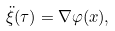Convert formula to latex. <formula><loc_0><loc_0><loc_500><loc_500>\ddot { \xi } ( \tau ) = \nabla \varphi ( x ) ,</formula> 